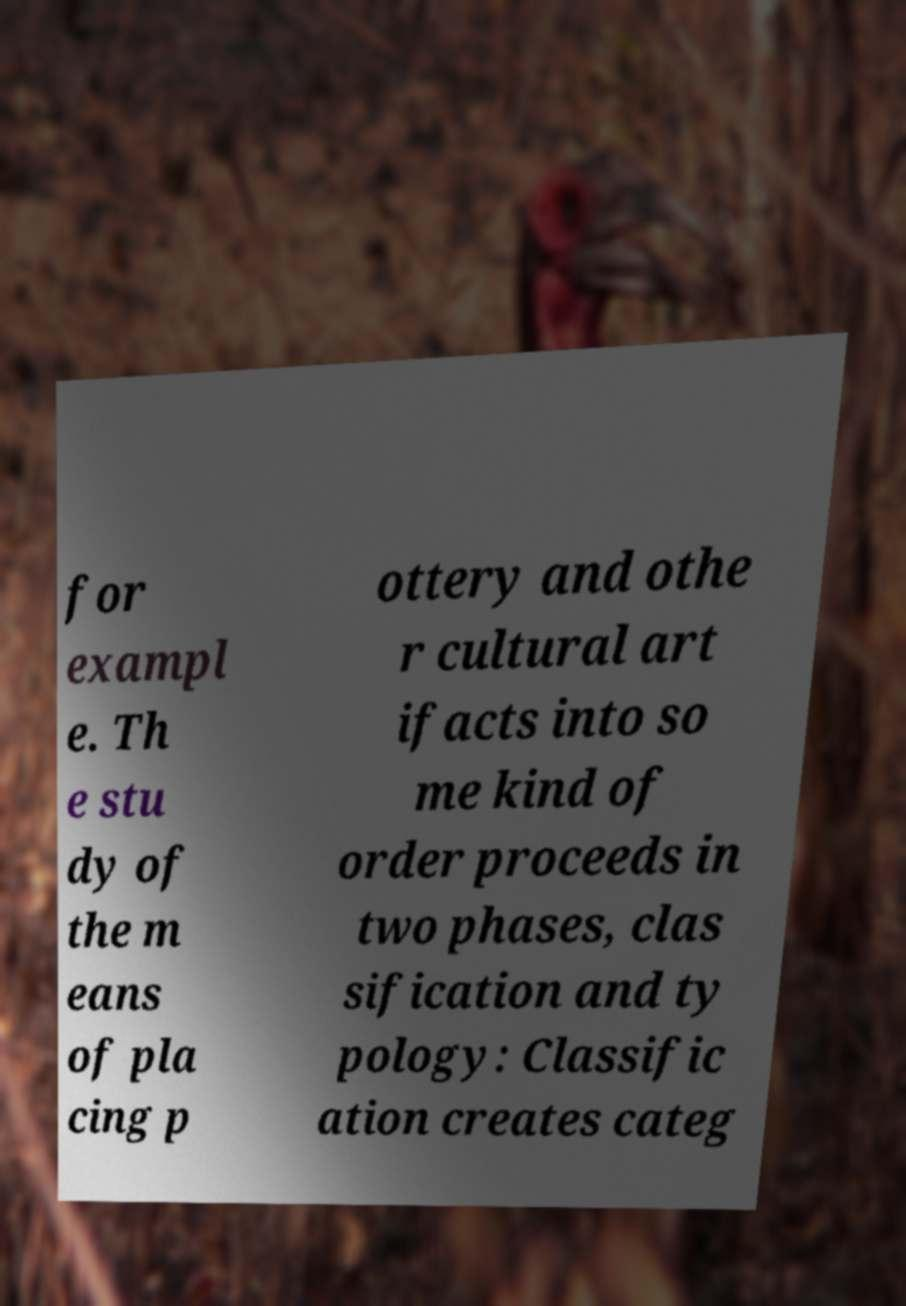What messages or text are displayed in this image? I need them in a readable, typed format. for exampl e. Th e stu dy of the m eans of pla cing p ottery and othe r cultural art ifacts into so me kind of order proceeds in two phases, clas sification and ty pology: Classific ation creates categ 